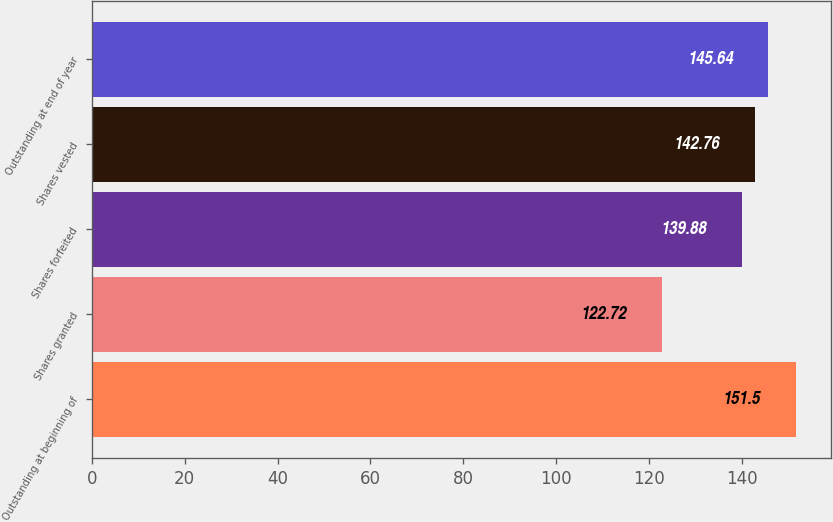<chart> <loc_0><loc_0><loc_500><loc_500><bar_chart><fcel>Outstanding at beginning of<fcel>Shares granted<fcel>Shares forfeited<fcel>Shares vested<fcel>Outstanding at end of year<nl><fcel>151.5<fcel>122.72<fcel>139.88<fcel>142.76<fcel>145.64<nl></chart> 